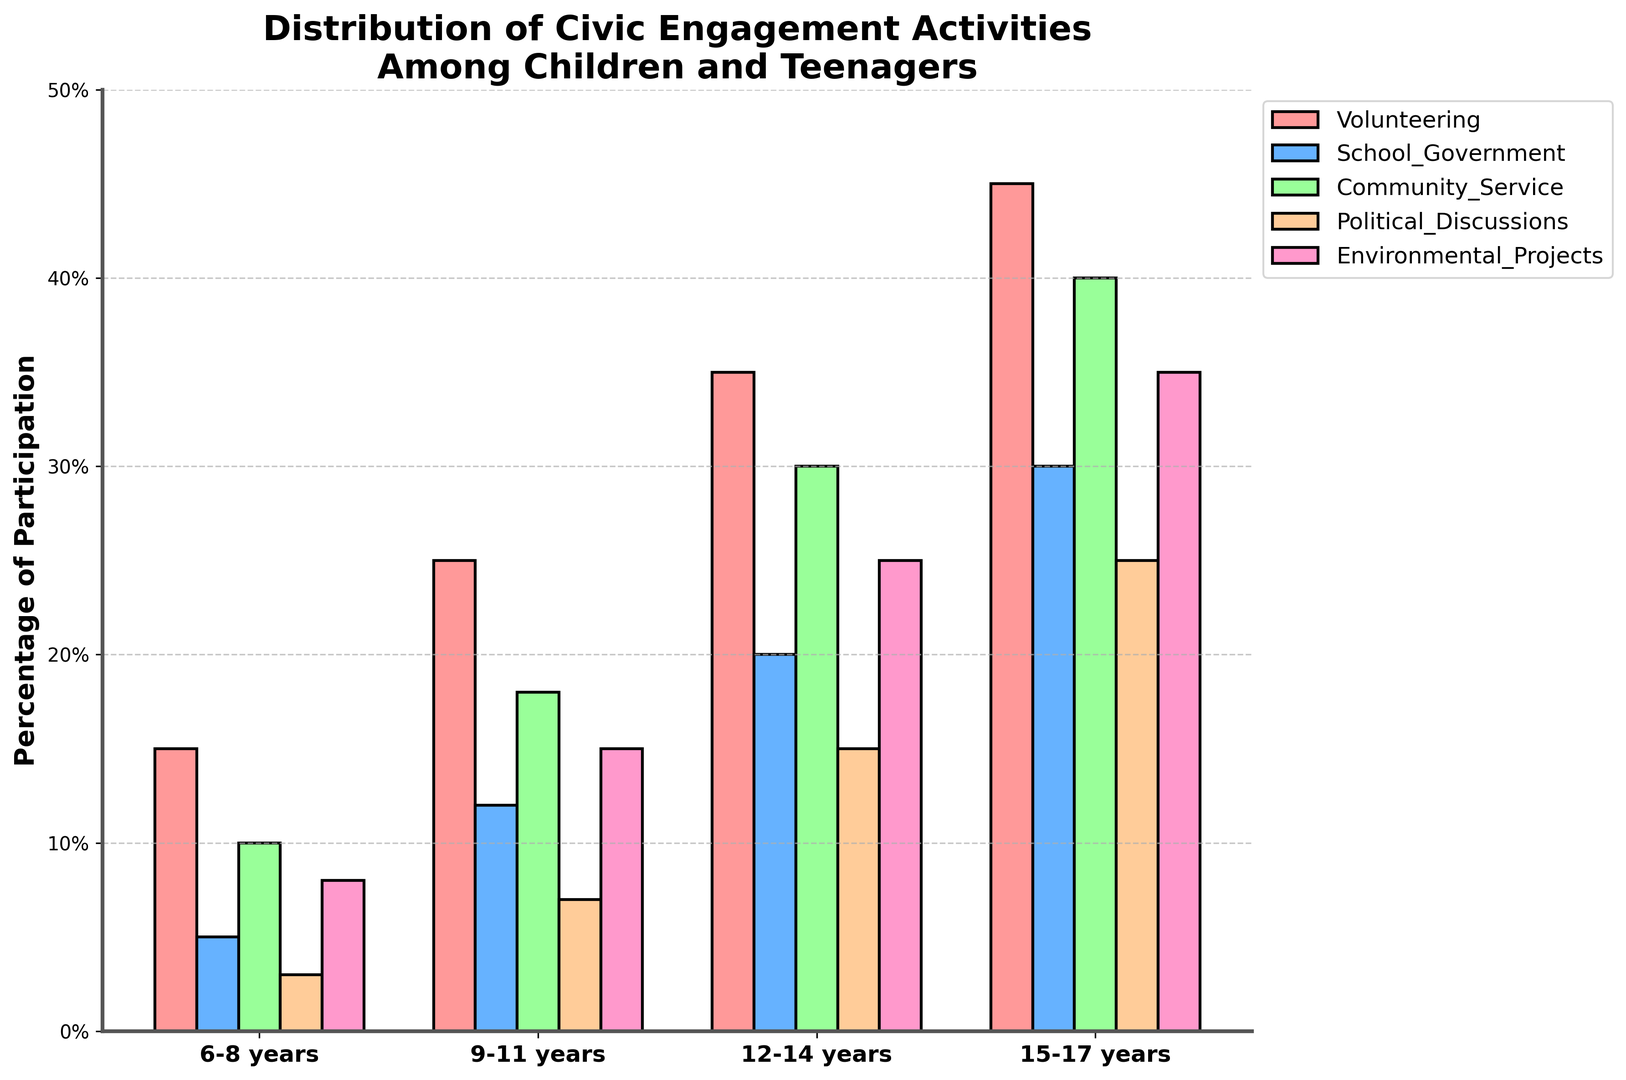Which age group volunteers the most? The tallest bar in the "Volunteering" section indicates the age group with the highest percentage. The bar for 15-17 years is the tallest at 45%.
Answer: 15-17 years Which activity has the highest participation among 12-14-year-olds? Among the bars corresponding to the 12-14 years group, the "Community Service" bar is the highest. Its height indicates 30%.
Answer: Community Service Compare the participation in School Government between the 9-11 years and 15-17 years groups. Which is higher? The bars for "School Government" show that the 15-17 years group has a higher percentage (30%) compared to the 9-11 years group (12%).
Answer: 15-17 years How much greater is the participation in political discussions for 15-17 years compared to 6-8 years? The height of the bar for 15-17 years (25%) minus the height of the bar for 6-8 years (3%) is 25% - 3% = 22%.
Answer: 22% What is the average participation in Environmental Projects across all age groups? Add the heights of the bars for Environmental Projects across all age groups (8% + 15% + 25% + 35%), then divide by the number of age groups (4). The calculation is (8 + 15 + 25 + 35) / 4 = 20.75%.
Answer: 20.75% Which activity has the smallest difference in participation between the oldest and youngest age groups? Calculate the differences for each activity: Volunteering (45% - 15% = 30%), School Government (30% - 5% = 25%), Community Service (40% - 10% = 30%), Political Discussions (25% - 3% = 22%), Environmental Projects (35% - 8% = 27%). The smallest difference is 22% for Political Discussions.
Answer: Political Discussions By how much does the participation in Community Service increase from 6-8 years to 12-14 years? Subtract the Community Service percentage of 6-8 years (10%) from that of 12-14 years (30%), which gives 30% - 10% = 20%.
Answer: 20% In which activity does the participation double from 9-11 years to 15-17 years? Look for activities where the height of the bar for 15-17 years is approximately twice that of 9-11 years. In "Political Discussions", the percentage goes from 7% to 25%, which is more than double.
Answer: Political Discussions 